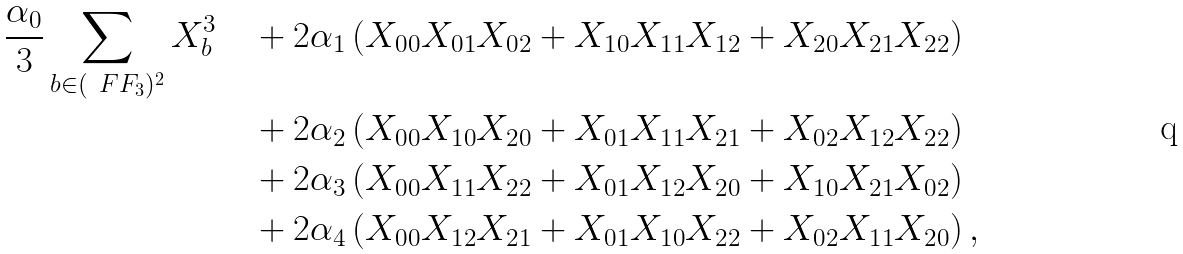Convert formula to latex. <formula><loc_0><loc_0><loc_500><loc_500>\frac { \alpha _ { 0 } } { 3 } \sum _ { b \in ( \ F F _ { 3 } ) ^ { 2 } } X _ { b } ^ { 3 } \quad & + 2 \alpha _ { 1 } \left ( X _ { 0 0 } X _ { 0 1 } X _ { 0 2 } + X _ { 1 0 } X _ { 1 1 } X _ { 1 2 } + X _ { 2 0 } X _ { 2 1 } X _ { 2 2 } \right ) \\ & + 2 \alpha _ { 2 } \left ( X _ { 0 0 } X _ { 1 0 } X _ { 2 0 } + X _ { 0 1 } X _ { 1 1 } X _ { 2 1 } + X _ { 0 2 } X _ { 1 2 } X _ { 2 2 } \right ) \\ & + 2 \alpha _ { 3 } \left ( X _ { 0 0 } X _ { 1 1 } X _ { 2 2 } + X _ { 0 1 } X _ { 1 2 } X _ { 2 0 } + X _ { 1 0 } X _ { 2 1 } X _ { 0 2 } \right ) \\ & + 2 \alpha _ { 4 } \left ( X _ { 0 0 } X _ { 1 2 } X _ { 2 1 } + X _ { 0 1 } X _ { 1 0 } X _ { 2 2 } + X _ { 0 2 } X _ { 1 1 } X _ { 2 0 } \right ) ,</formula> 